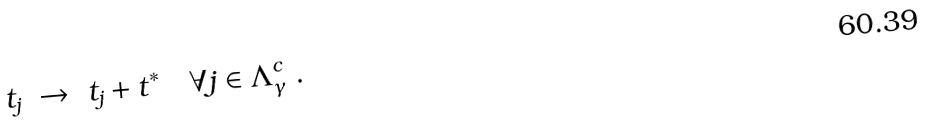<formula> <loc_0><loc_0><loc_500><loc_500>t _ { j } \ \rightarrow \ t _ { j } + t ^ { * } \quad \forall j \in \Lambda ^ { c } _ { \gamma } \ .</formula> 